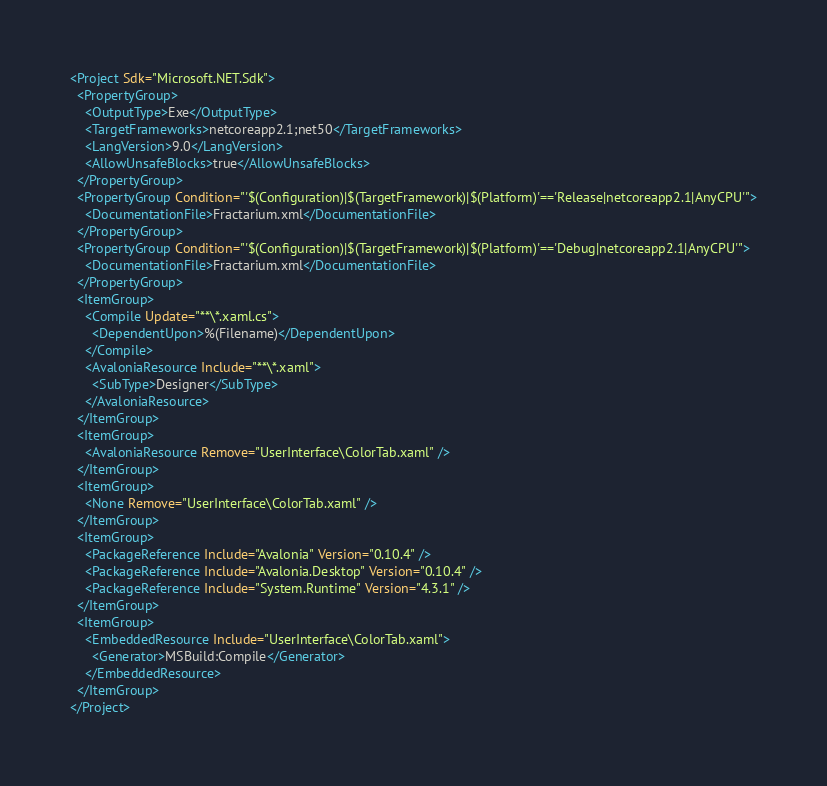<code> <loc_0><loc_0><loc_500><loc_500><_XML_><Project Sdk="Microsoft.NET.Sdk">
  <PropertyGroup>
    <OutputType>Exe</OutputType>
    <TargetFrameworks>netcoreapp2.1;net50</TargetFrameworks>
	<LangVersion>9.0</LangVersion>
    <AllowUnsafeBlocks>true</AllowUnsafeBlocks>
  </PropertyGroup>
  <PropertyGroup Condition="'$(Configuration)|$(TargetFramework)|$(Platform)'=='Release|netcoreapp2.1|AnyCPU'">
    <DocumentationFile>Fractarium.xml</DocumentationFile>
  </PropertyGroup>
  <PropertyGroup Condition="'$(Configuration)|$(TargetFramework)|$(Platform)'=='Debug|netcoreapp2.1|AnyCPU'">
    <DocumentationFile>Fractarium.xml</DocumentationFile>
  </PropertyGroup>
  <ItemGroup>
    <Compile Update="**\*.xaml.cs">
      <DependentUpon>%(Filename)</DependentUpon>
    </Compile>
    <AvaloniaResource Include="**\*.xaml">
      <SubType>Designer</SubType>
    </AvaloniaResource>
  </ItemGroup>
  <ItemGroup>
    <AvaloniaResource Remove="UserInterface\ColorTab.xaml" />
  </ItemGroup>
  <ItemGroup>
    <None Remove="UserInterface\ColorTab.xaml" />
  </ItemGroup>
  <ItemGroup>
    <PackageReference Include="Avalonia" Version="0.10.4" />
    <PackageReference Include="Avalonia.Desktop" Version="0.10.4" />
    <PackageReference Include="System.Runtime" Version="4.3.1" />
  </ItemGroup>
  <ItemGroup>
    <EmbeddedResource Include="UserInterface\ColorTab.xaml">
      <Generator>MSBuild:Compile</Generator>
    </EmbeddedResource>
  </ItemGroup>
</Project>
</code> 